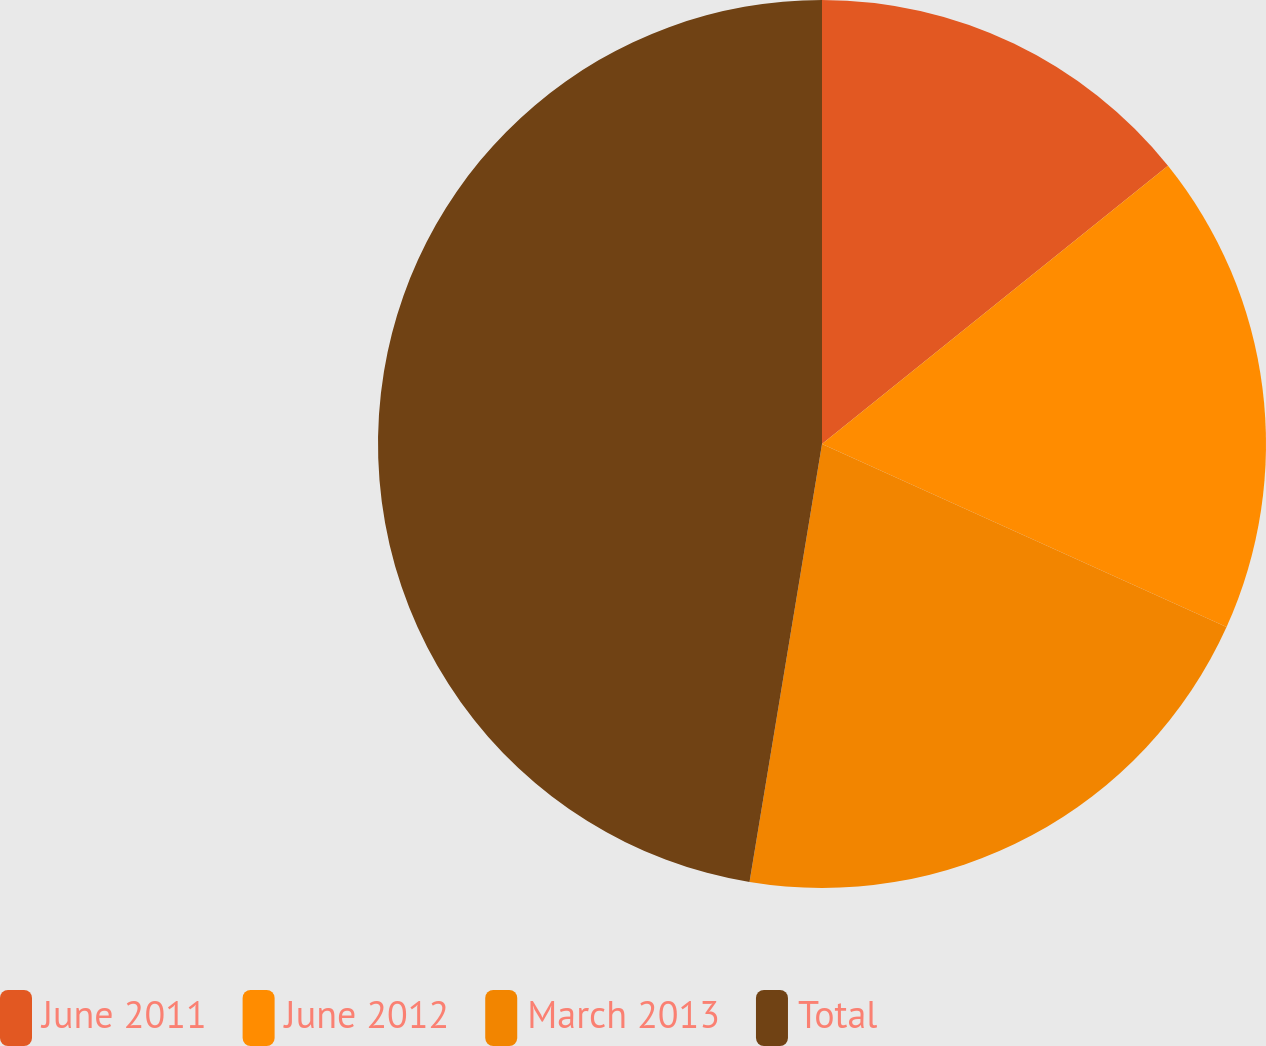<chart> <loc_0><loc_0><loc_500><loc_500><pie_chart><fcel>June 2011<fcel>June 2012<fcel>March 2013<fcel>Total<nl><fcel>14.22%<fcel>17.54%<fcel>20.85%<fcel>47.39%<nl></chart> 